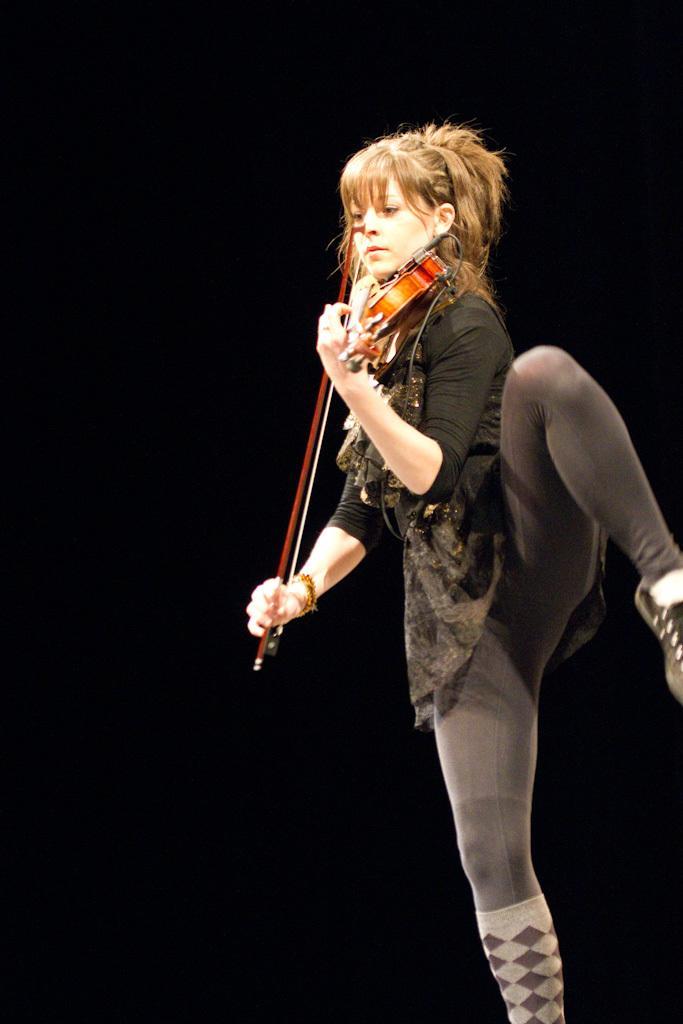Could you give a brief overview of what you see in this image? In this picture we see a woman standing on one leg and playing a violin 